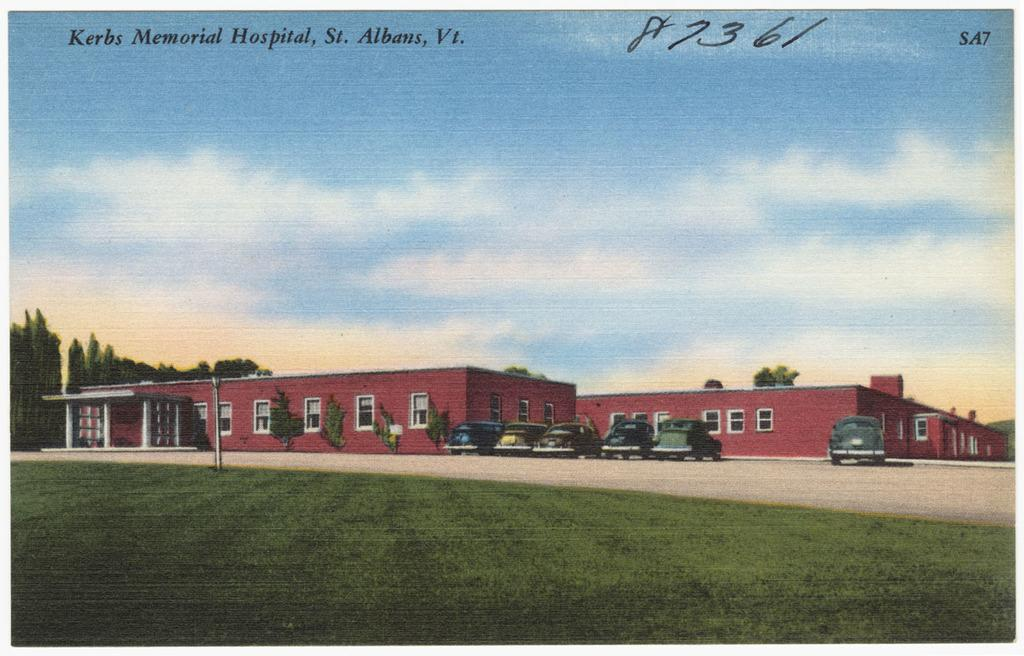What type of terrain is at the bottom of the image? There is a grassy land at the bottom of the image. What mode of transportation can be seen in the image? Cars are visible in the image. What type of structures are present in the image? Buildings are present in the image. What type of vegetation is in the image? Trees are in the image. What is the condition of the sky in the image? The sky is cloudy and visible at the top of the image. What type of note is being passed between the trees in the image? There is no note being passed between the trees in the image; trees do not have the ability to pass notes. 